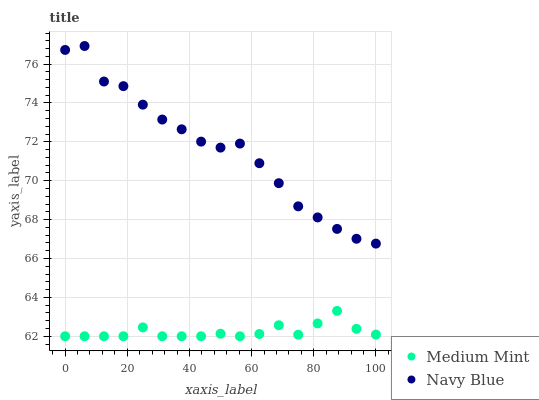Does Medium Mint have the minimum area under the curve?
Answer yes or no. Yes. Does Navy Blue have the maximum area under the curve?
Answer yes or no. Yes. Does Navy Blue have the minimum area under the curve?
Answer yes or no. No. Is Medium Mint the smoothest?
Answer yes or no. Yes. Is Navy Blue the roughest?
Answer yes or no. Yes. Is Navy Blue the smoothest?
Answer yes or no. No. Does Medium Mint have the lowest value?
Answer yes or no. Yes. Does Navy Blue have the lowest value?
Answer yes or no. No. Does Navy Blue have the highest value?
Answer yes or no. Yes. Is Medium Mint less than Navy Blue?
Answer yes or no. Yes. Is Navy Blue greater than Medium Mint?
Answer yes or no. Yes. Does Medium Mint intersect Navy Blue?
Answer yes or no. No. 